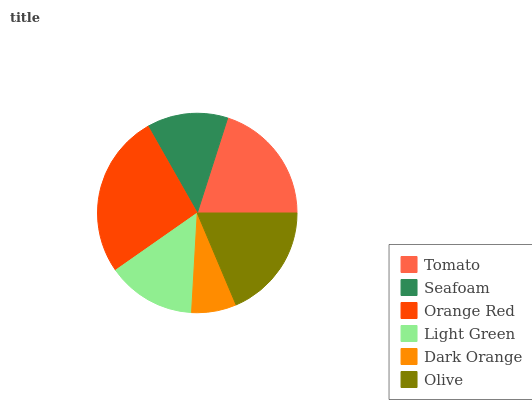Is Dark Orange the minimum?
Answer yes or no. Yes. Is Orange Red the maximum?
Answer yes or no. Yes. Is Seafoam the minimum?
Answer yes or no. No. Is Seafoam the maximum?
Answer yes or no. No. Is Tomato greater than Seafoam?
Answer yes or no. Yes. Is Seafoam less than Tomato?
Answer yes or no. Yes. Is Seafoam greater than Tomato?
Answer yes or no. No. Is Tomato less than Seafoam?
Answer yes or no. No. Is Olive the high median?
Answer yes or no. Yes. Is Light Green the low median?
Answer yes or no. Yes. Is Light Green the high median?
Answer yes or no. No. Is Tomato the low median?
Answer yes or no. No. 